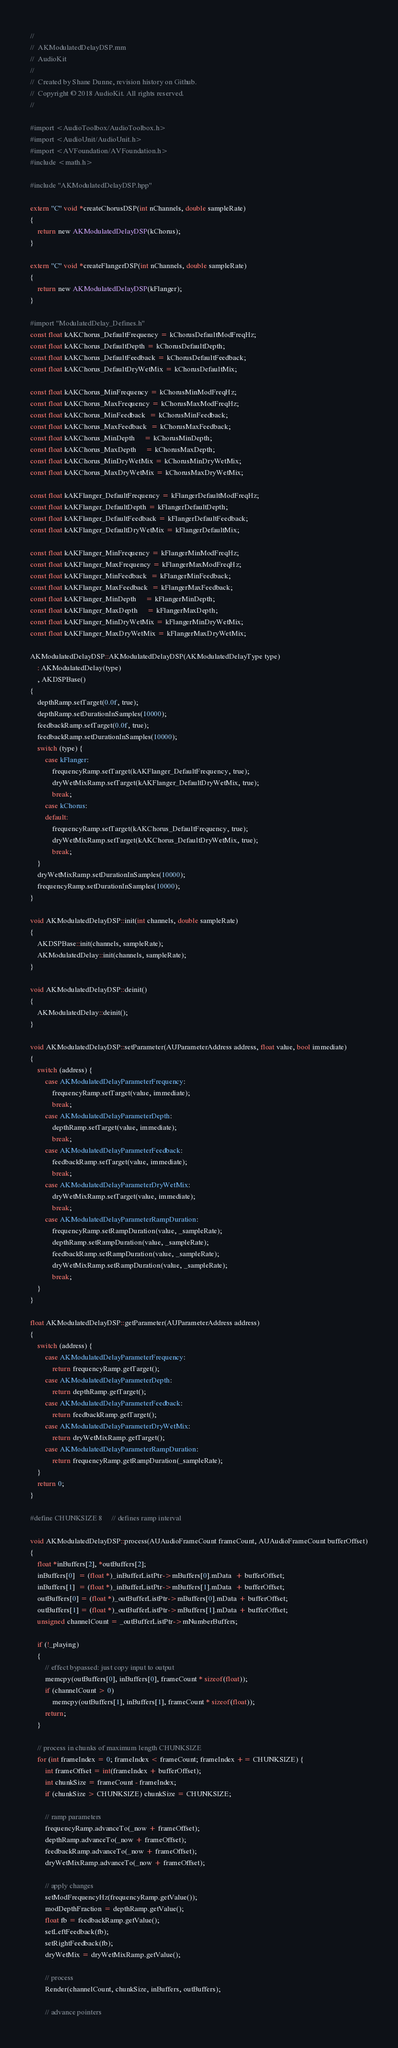Convert code to text. <code><loc_0><loc_0><loc_500><loc_500><_ObjectiveC_>//
//  AKModulatedDelayDSP.mm
//  AudioKit
//
//  Created by Shane Dunne, revision history on Github.
//  Copyright © 2018 AudioKit. All rights reserved.
//

#import <AudioToolbox/AudioToolbox.h>
#import <AudioUnit/AudioUnit.h>
#import <AVFoundation/AVFoundation.h>
#include <math.h>

#include "AKModulatedDelayDSP.hpp"

extern "C" void *createChorusDSP(int nChannels, double sampleRate)
{
    return new AKModulatedDelayDSP(kChorus);
}

extern "C" void *createFlangerDSP(int nChannels, double sampleRate)
{
    return new AKModulatedDelayDSP(kFlanger);
}

#import "ModulatedDelay_Defines.h"
const float kAKChorus_DefaultFrequency = kChorusDefaultModFreqHz;
const float kAKChorus_DefaultDepth = kChorusDefaultDepth;
const float kAKChorus_DefaultFeedback = kChorusDefaultFeedback;
const float kAKChorus_DefaultDryWetMix = kChorusDefaultMix;

const float kAKChorus_MinFrequency = kChorusMinModFreqHz;
const float kAKChorus_MaxFrequency = kChorusMaxModFreqHz;
const float kAKChorus_MinFeedback  = kChorusMinFeedback;
const float kAKChorus_MaxFeedback  = kChorusMaxFeedback;
const float kAKChorus_MinDepth     = kChorusMinDepth;
const float kAKChorus_MaxDepth     = kChorusMaxDepth;
const float kAKChorus_MinDryWetMix = kChorusMinDryWetMix;
const float kAKChorus_MaxDryWetMix = kChorusMaxDryWetMix;

const float kAKFlanger_DefaultFrequency = kFlangerDefaultModFreqHz;
const float kAKFlanger_DefaultDepth = kFlangerDefaultDepth;
const float kAKFlanger_DefaultFeedback = kFlangerDefaultFeedback;
const float kAKFlanger_DefaultDryWetMix = kFlangerDefaultMix;

const float kAKFlanger_MinFrequency = kFlangerMinModFreqHz;
const float kAKFlanger_MaxFrequency = kFlangerMaxModFreqHz;
const float kAKFlanger_MinFeedback  = kFlangerMinFeedback;
const float kAKFlanger_MaxFeedback  = kFlangerMaxFeedback;
const float kAKFlanger_MinDepth     = kFlangerMinDepth;
const float kAKFlanger_MaxDepth     = kFlangerMaxDepth;
const float kAKFlanger_MinDryWetMix = kFlangerMinDryWetMix;
const float kAKFlanger_MaxDryWetMix = kFlangerMaxDryWetMix;

AKModulatedDelayDSP::AKModulatedDelayDSP(AKModulatedDelayType type)
    : AKModulatedDelay(type)
    , AKDSPBase()
{
    depthRamp.setTarget(0.0f, true);
    depthRamp.setDurationInSamples(10000);
    feedbackRamp.setTarget(0.0f, true);
    feedbackRamp.setDurationInSamples(10000);
    switch (type) {
        case kFlanger:
            frequencyRamp.setTarget(kAKFlanger_DefaultFrequency, true);
            dryWetMixRamp.setTarget(kAKFlanger_DefaultDryWetMix, true);
            break;
        case kChorus:
        default:
            frequencyRamp.setTarget(kAKChorus_DefaultFrequency, true);
            dryWetMixRamp.setTarget(kAKChorus_DefaultDryWetMix, true);
            break;
    }
    dryWetMixRamp.setDurationInSamples(10000);
    frequencyRamp.setDurationInSamples(10000);
}

void AKModulatedDelayDSP::init(int channels, double sampleRate)
{
    AKDSPBase::init(channels, sampleRate);
    AKModulatedDelay::init(channels, sampleRate);
}

void AKModulatedDelayDSP::deinit()
{
    AKModulatedDelay::deinit();
}

void AKModulatedDelayDSP::setParameter(AUParameterAddress address, float value, bool immediate)
{
    switch (address) {
        case AKModulatedDelayParameterFrequency:
            frequencyRamp.setTarget(value, immediate);
            break;
        case AKModulatedDelayParameterDepth:
            depthRamp.setTarget(value, immediate);
            break;
        case AKModulatedDelayParameterFeedback:
            feedbackRamp.setTarget(value, immediate);
            break;
        case AKModulatedDelayParameterDryWetMix:
            dryWetMixRamp.setTarget(value, immediate);
            break;
        case AKModulatedDelayParameterRampDuration:
            frequencyRamp.setRampDuration(value, _sampleRate);
            depthRamp.setRampDuration(value, _sampleRate);
            feedbackRamp.setRampDuration(value, _sampleRate);
            dryWetMixRamp.setRampDuration(value, _sampleRate);
            break;
    }
}

float AKModulatedDelayDSP::getParameter(AUParameterAddress address)
{
    switch (address) {
        case AKModulatedDelayParameterFrequency:
            return frequencyRamp.getTarget();
        case AKModulatedDelayParameterDepth:
            return depthRamp.getTarget();
        case AKModulatedDelayParameterFeedback:
            return feedbackRamp.getTarget();
        case AKModulatedDelayParameterDryWetMix:
            return dryWetMixRamp.getTarget();
        case AKModulatedDelayParameterRampDuration:
            return frequencyRamp.getRampDuration(_sampleRate);
    }
    return 0;
}

#define CHUNKSIZE 8     // defines ramp interval

void AKModulatedDelayDSP::process(AUAudioFrameCount frameCount, AUAudioFrameCount bufferOffset)
{
    float *inBuffers[2], *outBuffers[2];
    inBuffers[0]  = (float *)_inBufferListPtr->mBuffers[0].mData  + bufferOffset;
    inBuffers[1]  = (float *)_inBufferListPtr->mBuffers[1].mData  + bufferOffset;
    outBuffers[0] = (float *)_outBufferListPtr->mBuffers[0].mData + bufferOffset;
    outBuffers[1] = (float *)_outBufferListPtr->mBuffers[1].mData + bufferOffset;
    unsigned channelCount = _outBufferListPtr->mNumberBuffers;

    if (!_playing)
    {
        // effect bypassed: just copy input to output
        memcpy(outBuffers[0], inBuffers[0], frameCount * sizeof(float));
        if (channelCount > 0)
            memcpy(outBuffers[1], inBuffers[1], frameCount * sizeof(float));
        return;
    }

    // process in chunks of maximum length CHUNKSIZE
    for (int frameIndex = 0; frameIndex < frameCount; frameIndex += CHUNKSIZE) {
        int frameOffset = int(frameIndex + bufferOffset);
        int chunkSize = frameCount - frameIndex;
        if (chunkSize > CHUNKSIZE) chunkSize = CHUNKSIZE;
        
        // ramp parameters
        frequencyRamp.advanceTo(_now + frameOffset);
        depthRamp.advanceTo(_now + frameOffset);
        feedbackRamp.advanceTo(_now + frameOffset);
        dryWetMixRamp.advanceTo(_now + frameOffset);
        
        // apply changes
        setModFrequencyHz(frequencyRamp.getValue());
        modDepthFraction = depthRamp.getValue();
        float fb = feedbackRamp.getValue();
        setLeftFeedback(fb);
        setRightFeedback(fb);
        dryWetMix = dryWetMixRamp.getValue();

        // process
        Render(channelCount, chunkSize, inBuffers, outBuffers);
        
        // advance pointers</code> 